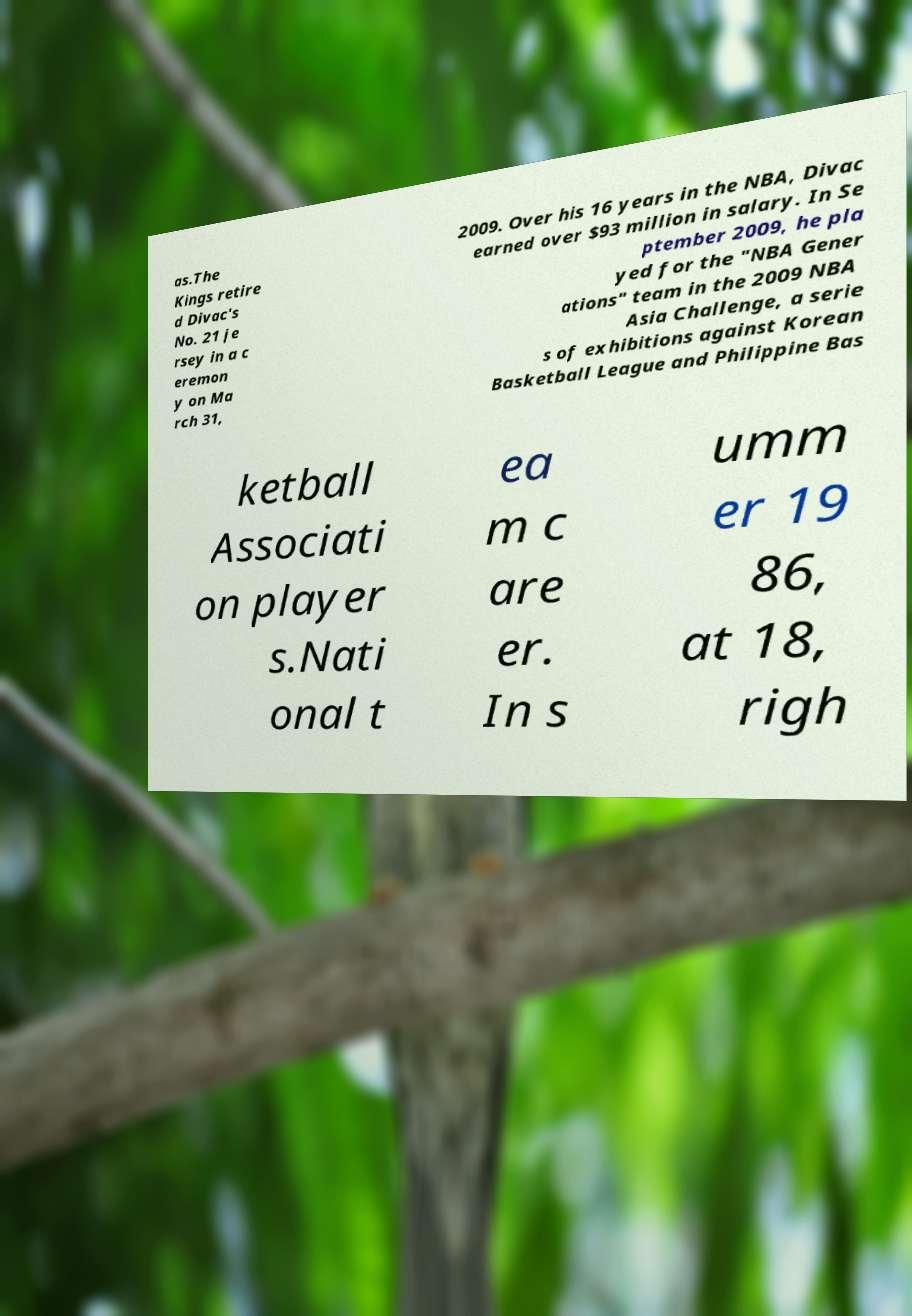Please identify and transcribe the text found in this image. as.The Kings retire d Divac's No. 21 je rsey in a c eremon y on Ma rch 31, 2009. Over his 16 years in the NBA, Divac earned over $93 million in salary. In Se ptember 2009, he pla yed for the "NBA Gener ations" team in the 2009 NBA Asia Challenge, a serie s of exhibitions against Korean Basketball League and Philippine Bas ketball Associati on player s.Nati onal t ea m c are er. In s umm er 19 86, at 18, righ 